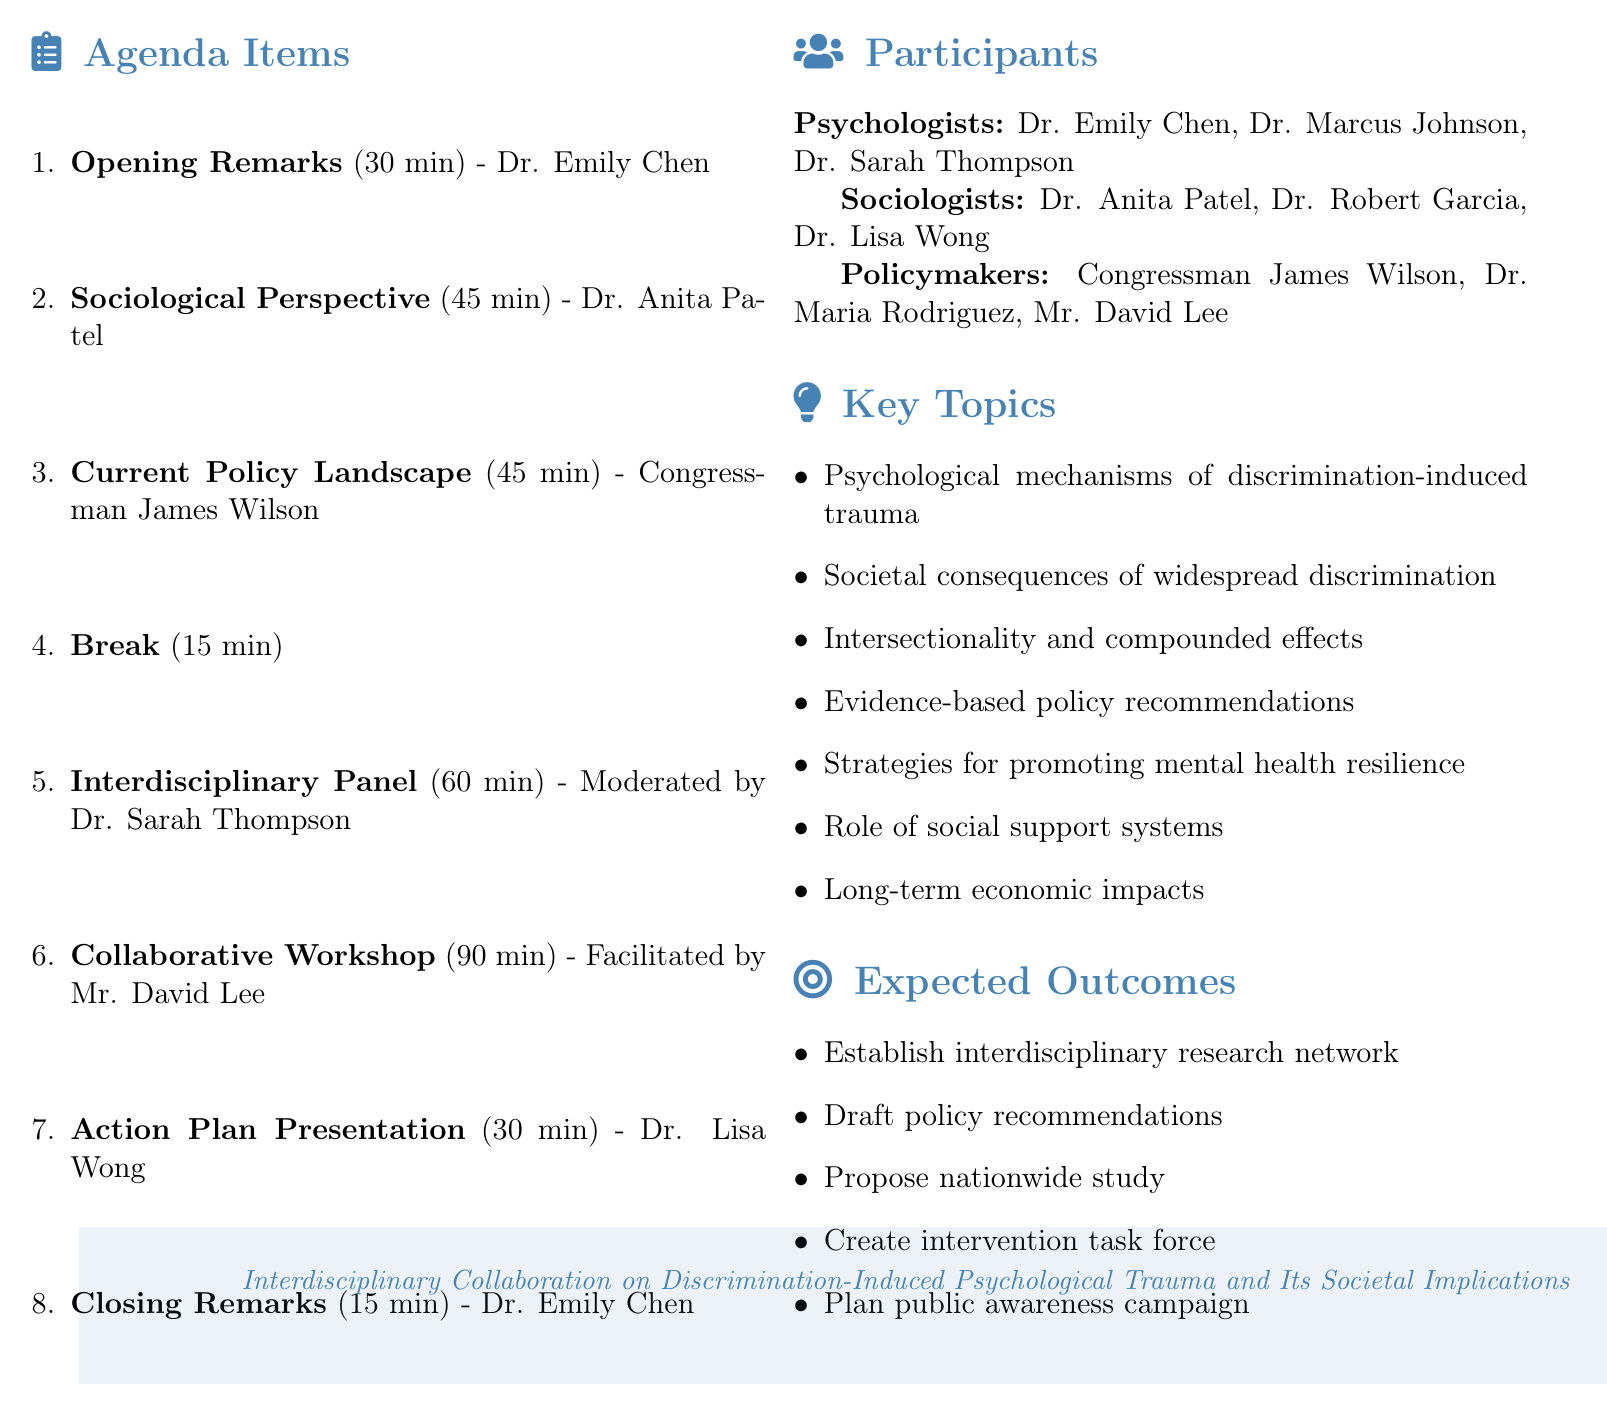What is the date of the meeting? The date of the meeting is listed at the top of the agenda document.
Answer: October 15, 2023 Where is the meeting venue? The venue is specified in the header section of the agenda.
Answer: National Institute of Mental Health, Bethesda, MD Who is presenting the sociological perspective? The agenda lists the speaker for this item.
Answer: Dr. Anita Patel How long is the collaborative workshop planned to last? The duration is specified next to the agenda item.
Answer: 90 minutes What are the key topics discussed in the meeting? The key topics are outlined in a bullet point format within the agenda.
Answer: Psychological mechanisms of discrimination-induced trauma Who will moderate the interdisciplinary panel discussion? The moderator's name is provided next to the panel discussion item.
Answer: Dr. Sarah Thompson What is one expected outcome of the meeting? The expected outcomes are listed in a category on the agenda.
Answer: Establish interdisciplinary research network What is the total duration of opening remarks and introduction? The durations of each meeting agenda item can be summed for this section.
Answer: 30 minutes 